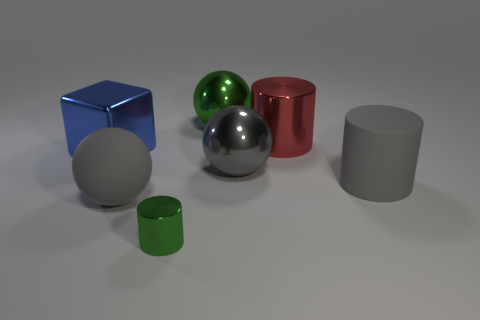Add 1 small matte things. How many objects exist? 8 Subtract all cylinders. How many objects are left? 4 Subtract all purple things. Subtract all metallic cylinders. How many objects are left? 5 Add 3 blue metal blocks. How many blue metal blocks are left? 4 Add 7 gray things. How many gray things exist? 10 Subtract 1 green spheres. How many objects are left? 6 